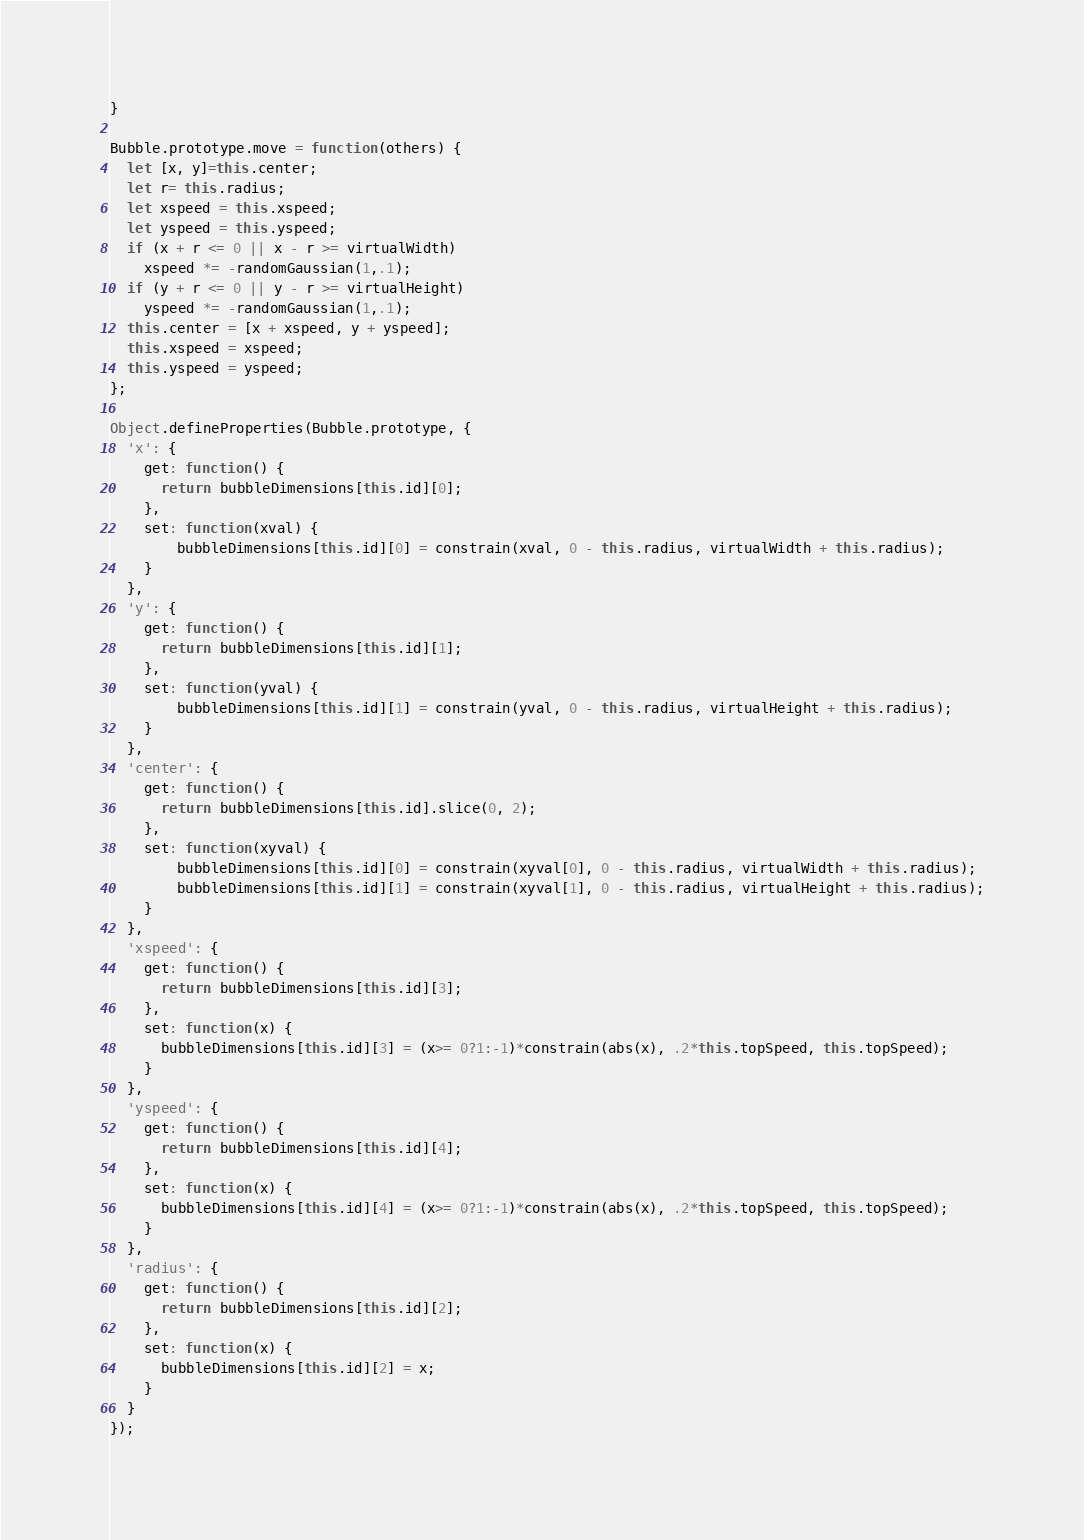Convert code to text. <code><loc_0><loc_0><loc_500><loc_500><_JavaScript_>}

Bubble.prototype.move = function(others) {
  let [x, y]=this.center;
  let r= this.radius;
  let xspeed = this.xspeed;
  let yspeed = this.yspeed;
  if (x + r <= 0 || x - r >= virtualWidth)
    xspeed *= -randomGaussian(1,.1);
  if (y + r <= 0 || y - r >= virtualHeight)
    yspeed *= -randomGaussian(1,.1);
  this.center = [x + xspeed, y + yspeed];
  this.xspeed = xspeed;
  this.yspeed = yspeed;
};

Object.defineProperties(Bubble.prototype, {
  'x': {
    get: function() {
      return bubbleDimensions[this.id][0];
    },
    set: function(xval) {
        bubbleDimensions[this.id][0] = constrain(xval, 0 - this.radius, virtualWidth + this.radius);
    }
  },
  'y': {
    get: function() {
      return bubbleDimensions[this.id][1];
    },
    set: function(yval) {
        bubbleDimensions[this.id][1] = constrain(yval, 0 - this.radius, virtualHeight + this.radius);
    }
  },
  'center': {
    get: function() {
      return bubbleDimensions[this.id].slice(0, 2);
    },
    set: function(xyval) {
        bubbleDimensions[this.id][0] = constrain(xyval[0], 0 - this.radius, virtualWidth + this.radius);
        bubbleDimensions[this.id][1] = constrain(xyval[1], 0 - this.radius, virtualHeight + this.radius);
    }
  },
  'xspeed': {
    get: function() {
      return bubbleDimensions[this.id][3];
    },
    set: function(x) {
      bubbleDimensions[this.id][3] = (x>= 0?1:-1)*constrain(abs(x), .2*this.topSpeed, this.topSpeed);
    }
  },
  'yspeed': {
    get: function() {
      return bubbleDimensions[this.id][4];
    },
    set: function(x) {
      bubbleDimensions[this.id][4] = (x>= 0?1:-1)*constrain(abs(x), .2*this.topSpeed, this.topSpeed);
    }
  },
  'radius': {
    get: function() {
      return bubbleDimensions[this.id][2];
    },
    set: function(x) {
      bubbleDimensions[this.id][2] = x;
    }
  }
});
</code> 